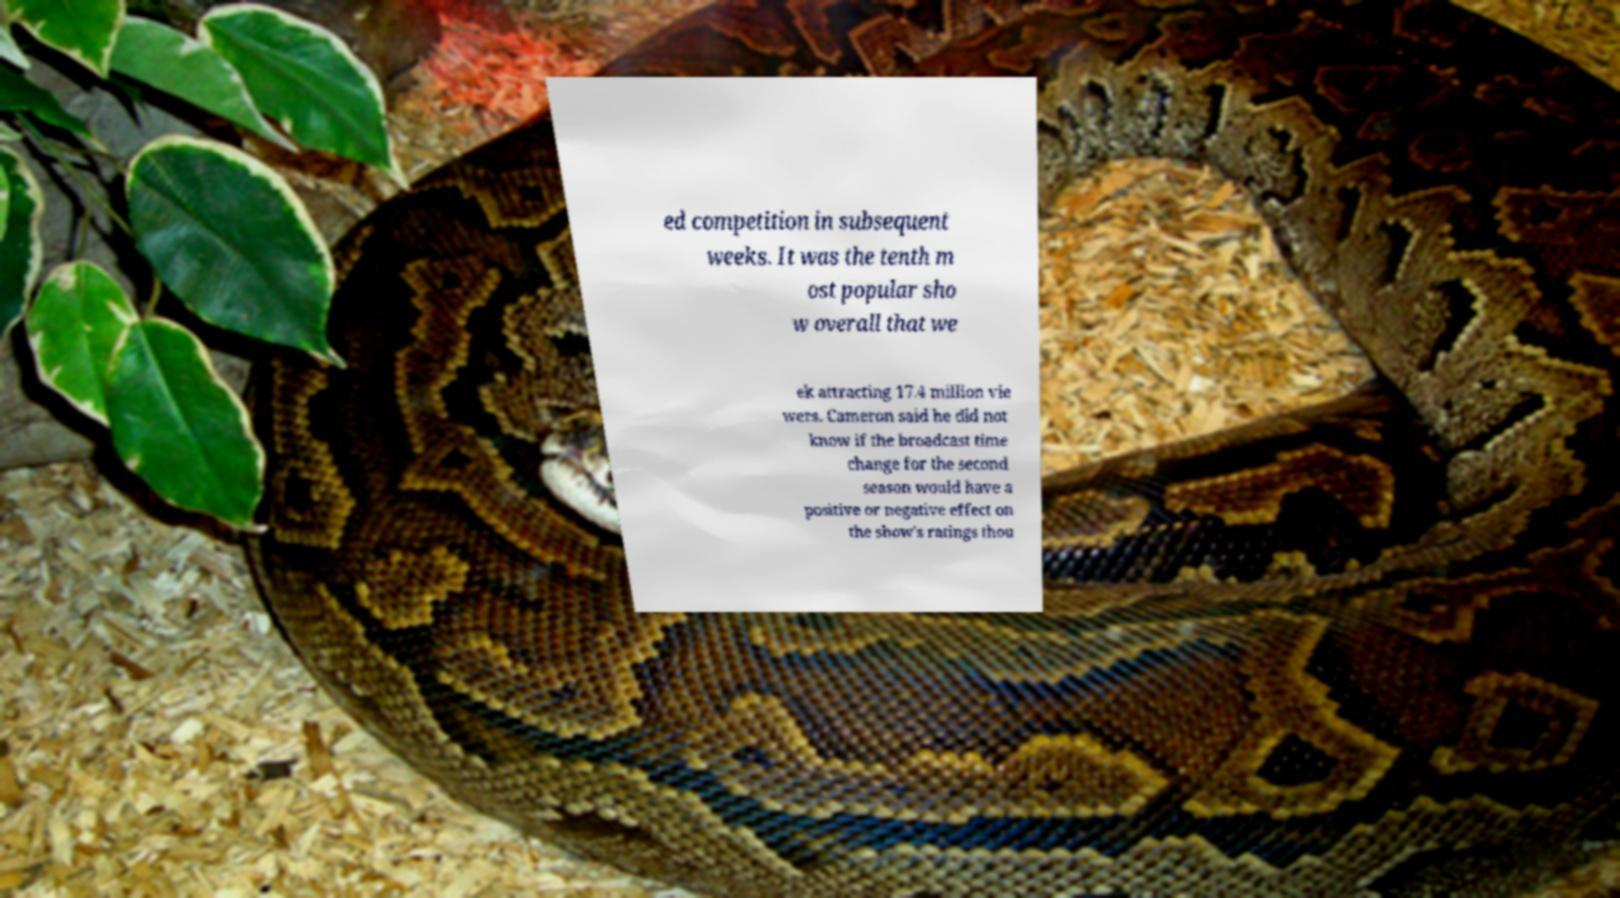Could you assist in decoding the text presented in this image and type it out clearly? ed competition in subsequent weeks. It was the tenth m ost popular sho w overall that we ek attracting 17.4 million vie wers. Cameron said he did not know if the broadcast time change for the second season would have a positive or negative effect on the show's ratings thou 